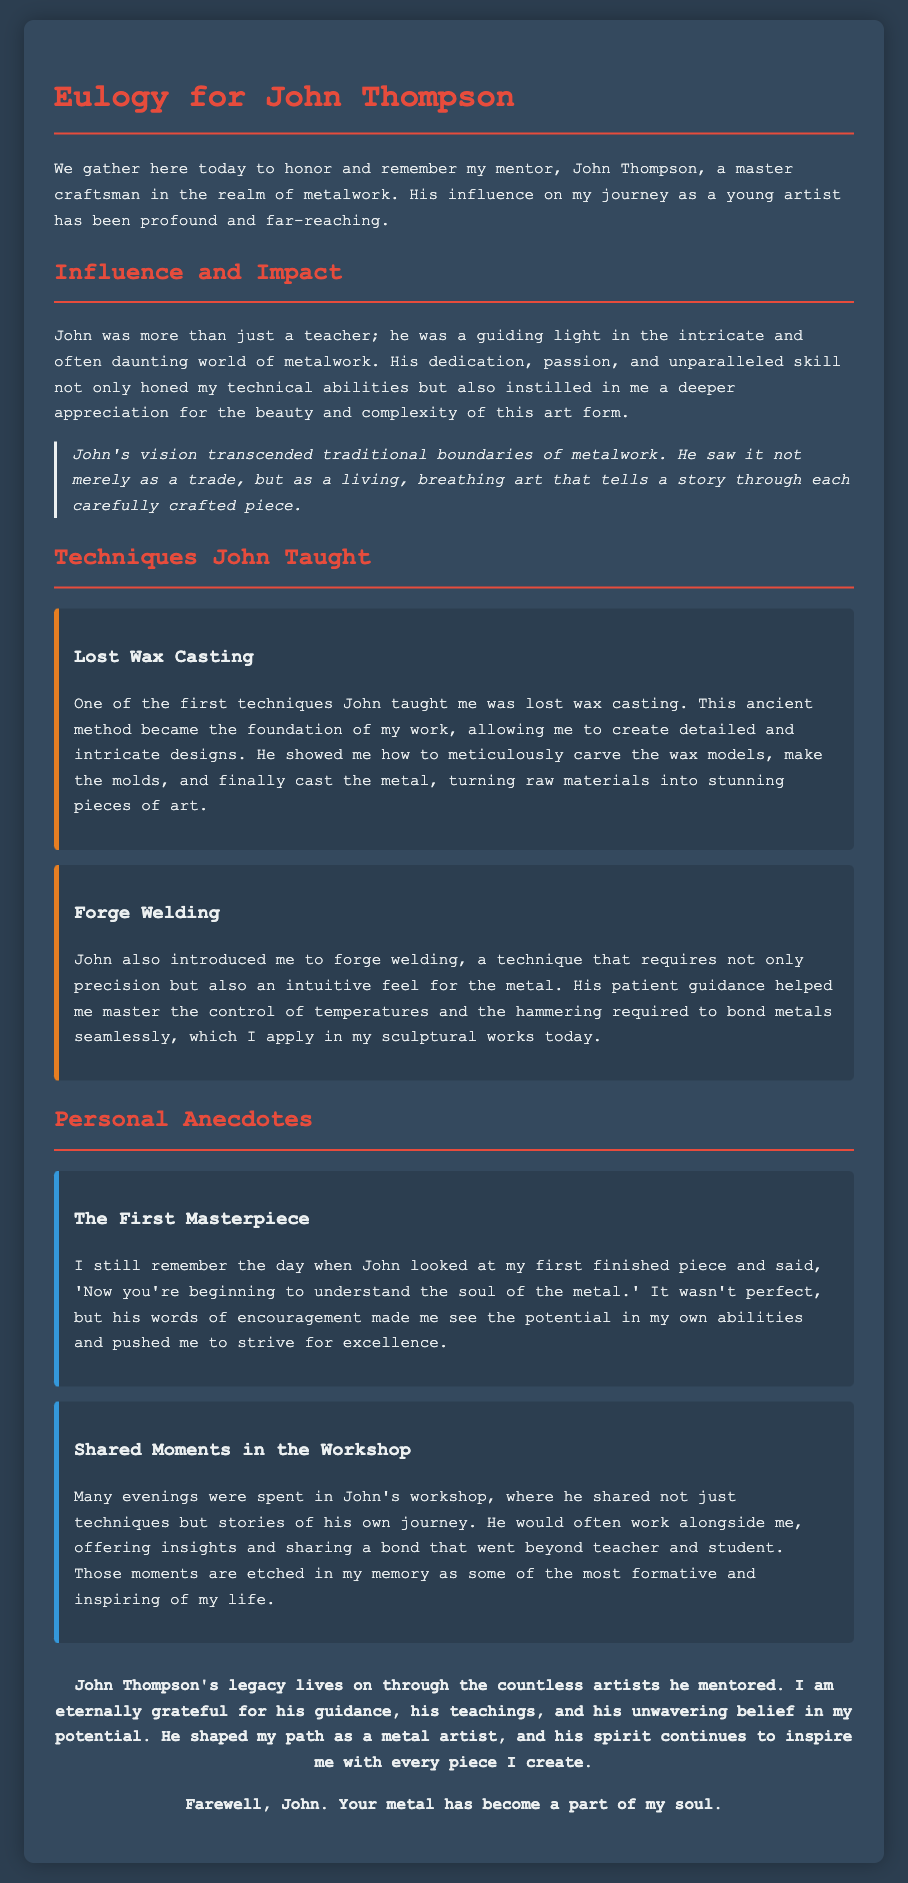What is the name of the mentor being honored? The document specifically honors John Thompson as the mentor.
Answer: John Thompson Which technique was introduced first by John? The first technique taught by John was lost wax casting, as mentioned in the document.
Answer: Lost Wax Casting What quality did John instill in the author regarding metalwork? The document states John instilled a deeper appreciation for the beauty and complexity of metalwork.
Answer: Deeper appreciation What is a personal memory shared in the document related to the author's first finished piece? The author recalls John's words, indicating the potential in their abilities with the quote provided.
Answer: "Now you're beginning to understand the soul of the metal." How did John view metalwork, according to the eulogy? John viewed metalwork as a living, breathing art that tells a story.
Answer: A living, breathing art What type of anecdote features shared moments in the workshop? The document shares a personal anecdote about spending evenings in John's workshop, gaining insights and stories.
Answer: Shared Moments in the Workshop Which technique taught by John involves precision and intuitive feel for metal? Forge welding requires precision and an intuitive feel for the metal, as described in the eulogy.
Answer: Forge welding What does the author express gratitude for in the closing statement? The author expresses gratitude for guidance, teachings, and belief in potential throughout the eulogy.
Answer: Guidance, teachings, and belief in potential 